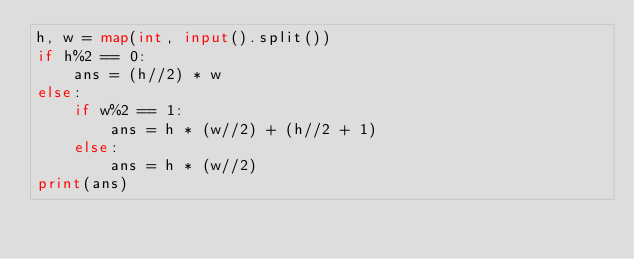<code> <loc_0><loc_0><loc_500><loc_500><_Python_>h, w = map(int, input().split())
if h%2 == 0:
    ans = (h//2) * w
else:
    if w%2 == 1:
        ans = h * (w//2) + (h//2 + 1)
    else:
        ans = h * (w//2)
print(ans)</code> 